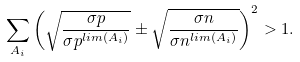<formula> <loc_0><loc_0><loc_500><loc_500>\sum _ { A _ { i } } \left ( \sqrt { \frac { \sigma p } { \sigma p ^ { l i m ( A _ { i } ) } } } \pm \sqrt { \frac { \sigma n } { \sigma n ^ { l i m ( A _ { i } ) } } } \right ) ^ { 2 } > 1 .</formula> 